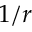Convert formula to latex. <formula><loc_0><loc_0><loc_500><loc_500>1 / r</formula> 